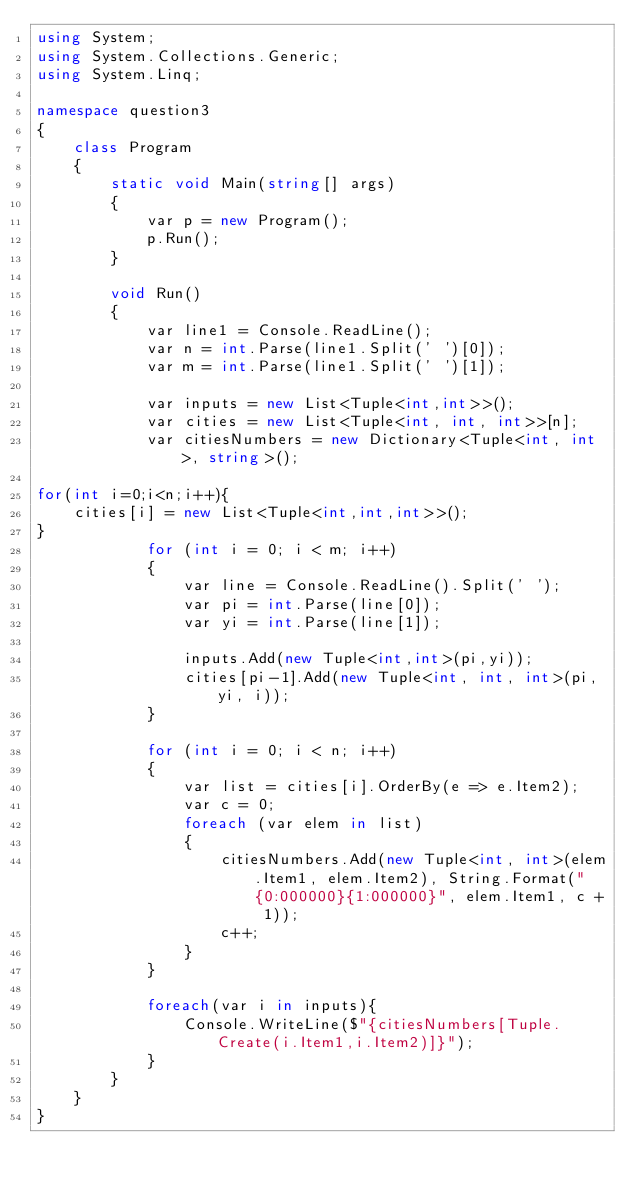Convert code to text. <code><loc_0><loc_0><loc_500><loc_500><_C#_>using System;
using System.Collections.Generic;
using System.Linq;

namespace question3
{
    class Program
    {
        static void Main(string[] args)
        {
            var p = new Program();
            p.Run();
        }

        void Run()
        {
            var line1 = Console.ReadLine();
            var n = int.Parse(line1.Split(' ')[0]);
            var m = int.Parse(line1.Split(' ')[1]);

            var inputs = new List<Tuple<int,int>>();
            var cities = new List<Tuple<int, int, int>>[n];
            var citiesNumbers = new Dictionary<Tuple<int, int>, string>();

for(int i=0;i<n;i++){
    cities[i] = new List<Tuple<int,int,int>>();
}
            for (int i = 0; i < m; i++)
            {
                var line = Console.ReadLine().Split(' ');
                var pi = int.Parse(line[0]);
                var yi = int.Parse(line[1]);

                inputs.Add(new Tuple<int,int>(pi,yi));
                cities[pi-1].Add(new Tuple<int, int, int>(pi, yi, i));
            }

            for (int i = 0; i < n; i++)
            {
                var list = cities[i].OrderBy(e => e.Item2);
                var c = 0;
                foreach (var elem in list)
                {
                    citiesNumbers.Add(new Tuple<int, int>(elem.Item1, elem.Item2), String.Format("{0:000000}{1:000000}", elem.Item1, c + 1));
                    c++;
                }
            }

            foreach(var i in inputs){
                Console.WriteLine($"{citiesNumbers[Tuple.Create(i.Item1,i.Item2)]}");
            }
        }
    }
}
</code> 